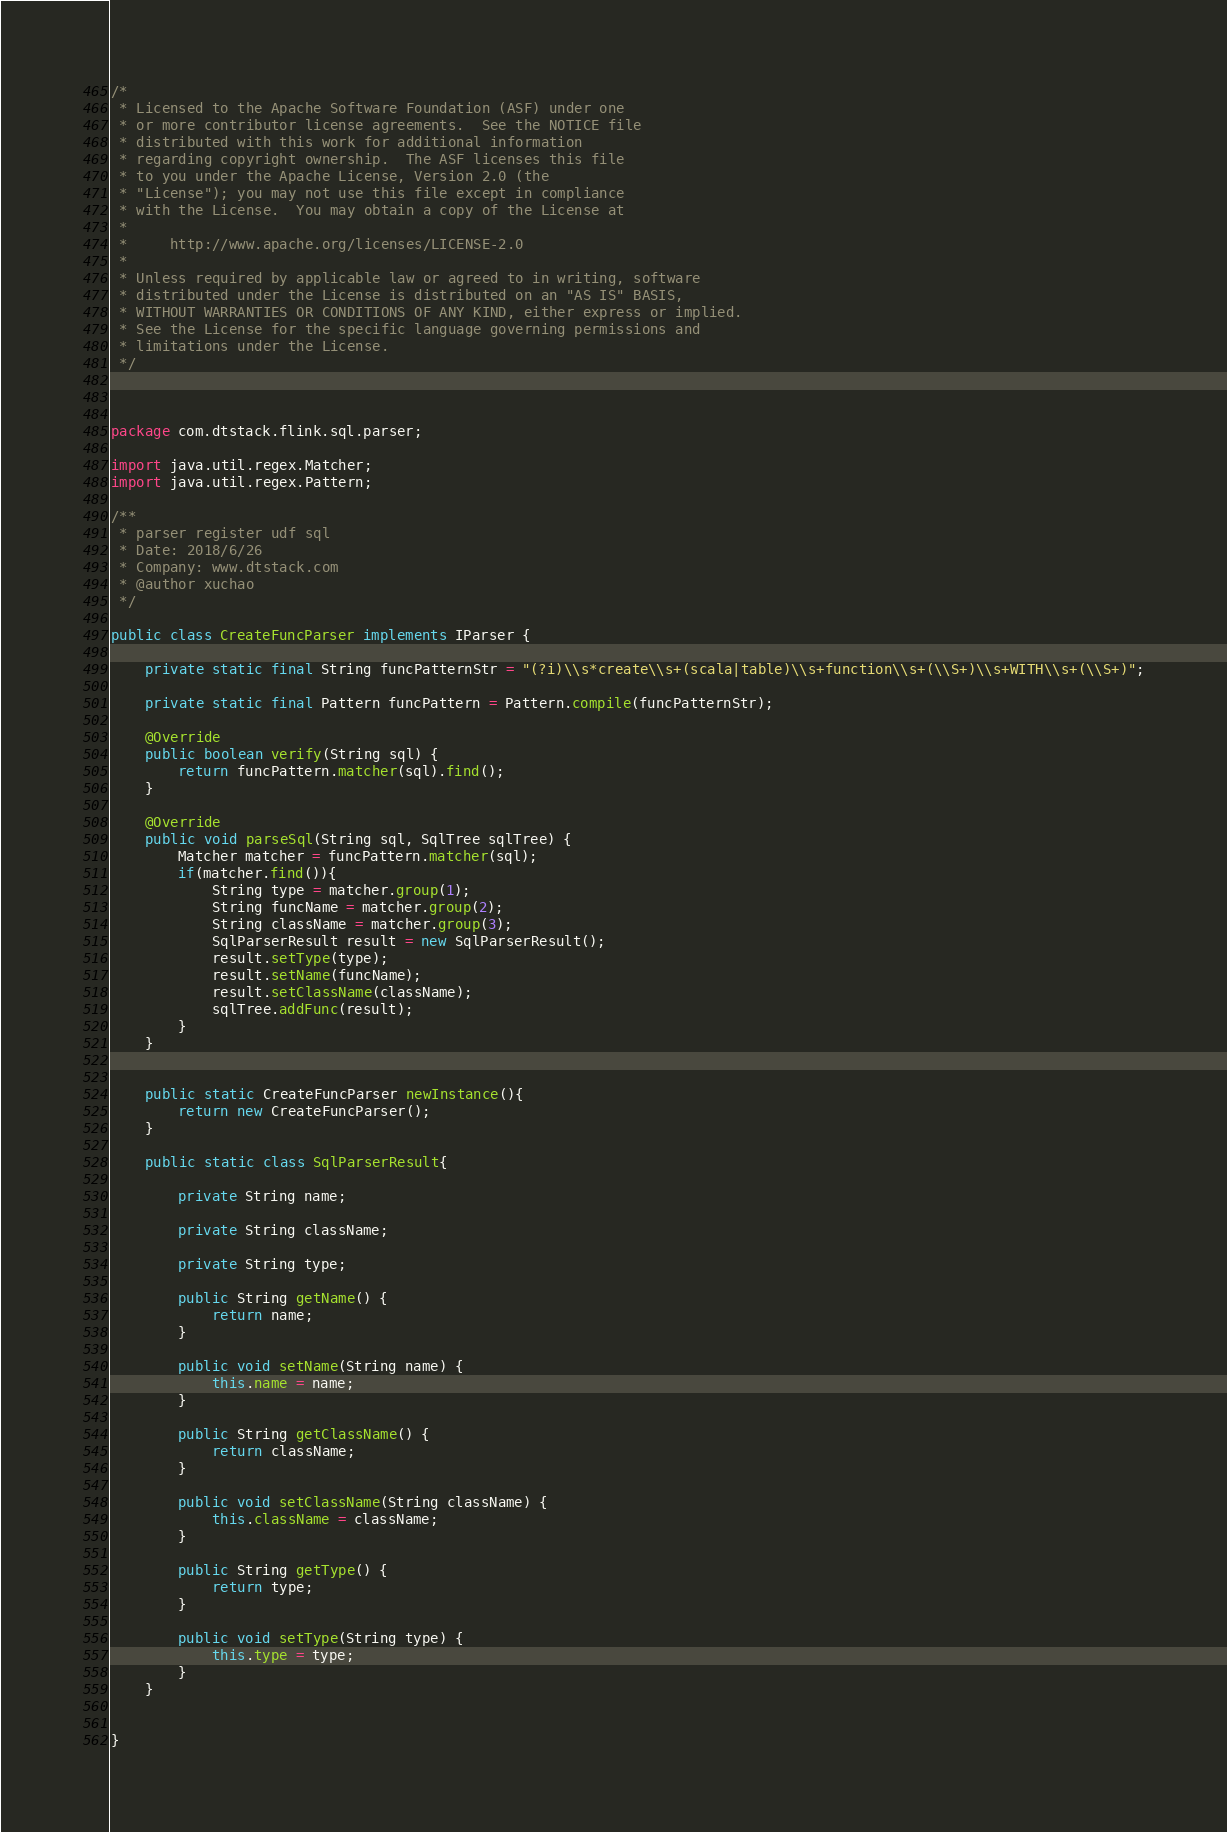Convert code to text. <code><loc_0><loc_0><loc_500><loc_500><_Java_>/*
 * Licensed to the Apache Software Foundation (ASF) under one
 * or more contributor license agreements.  See the NOTICE file
 * distributed with this work for additional information
 * regarding copyright ownership.  The ASF licenses this file
 * to you under the Apache License, Version 2.0 (the
 * "License"); you may not use this file except in compliance
 * with the License.  You may obtain a copy of the License at
 *
 *     http://www.apache.org/licenses/LICENSE-2.0
 *
 * Unless required by applicable law or agreed to in writing, software
 * distributed under the License is distributed on an "AS IS" BASIS,
 * WITHOUT WARRANTIES OR CONDITIONS OF ANY KIND, either express or implied.
 * See the License for the specific language governing permissions and
 * limitations under the License.
 */

 

package com.dtstack.flink.sql.parser;

import java.util.regex.Matcher;
import java.util.regex.Pattern;

/**
 * parser register udf sql
 * Date: 2018/6/26
 * Company: www.dtstack.com
 * @author xuchao
 */

public class CreateFuncParser implements IParser {

    private static final String funcPatternStr = "(?i)\\s*create\\s+(scala|table)\\s+function\\s+(\\S+)\\s+WITH\\s+(\\S+)";

    private static final Pattern funcPattern = Pattern.compile(funcPatternStr);

    @Override
    public boolean verify(String sql) {
        return funcPattern.matcher(sql).find();
    }

    @Override
    public void parseSql(String sql, SqlTree sqlTree) {
        Matcher matcher = funcPattern.matcher(sql);
        if(matcher.find()){
            String type = matcher.group(1);
            String funcName = matcher.group(2);
            String className = matcher.group(3);
            SqlParserResult result = new SqlParserResult();
            result.setType(type);
            result.setName(funcName);
            result.setClassName(className);
            sqlTree.addFunc(result);
        }
    }


    public static CreateFuncParser newInstance(){
        return new CreateFuncParser();
    }

    public static class SqlParserResult{

        private String name;

        private String className;

        private String type;

        public String getName() {
            return name;
        }

        public void setName(String name) {
            this.name = name;
        }

        public String getClassName() {
            return className;
        }

        public void setClassName(String className) {
            this.className = className;
        }

        public String getType() {
            return type;
        }

        public void setType(String type) {
            this.type = type;
        }
    }


}
</code> 